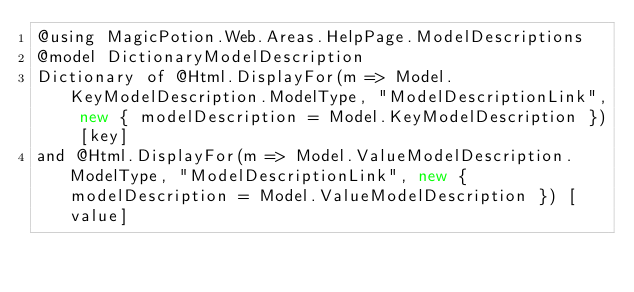<code> <loc_0><loc_0><loc_500><loc_500><_C#_>@using MagicPotion.Web.Areas.HelpPage.ModelDescriptions
@model DictionaryModelDescription
Dictionary of @Html.DisplayFor(m => Model.KeyModelDescription.ModelType, "ModelDescriptionLink", new { modelDescription = Model.KeyModelDescription }) [key]
and @Html.DisplayFor(m => Model.ValueModelDescription.ModelType, "ModelDescriptionLink", new { modelDescription = Model.ValueModelDescription }) [value]</code> 